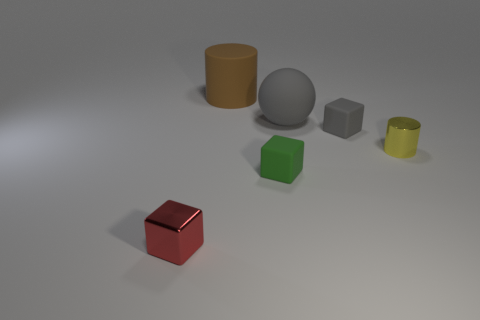What number of other objects are the same material as the small yellow cylinder?
Offer a terse response. 1. Are there the same number of large rubber objects in front of the tiny red metal block and tiny things left of the rubber cylinder?
Your answer should be compact. No. What is the color of the small rubber object that is behind the small object that is on the right side of the tiny cube behind the small yellow cylinder?
Keep it short and to the point. Gray. There is a metallic object that is on the right side of the brown matte object; what shape is it?
Your answer should be compact. Cylinder. The other gray object that is the same material as the small gray thing is what shape?
Provide a short and direct response. Sphere. Is there anything else that is the same shape as the big gray thing?
Offer a terse response. No. There is a large brown cylinder; how many red metallic objects are to the right of it?
Give a very brief answer. 0. Are there the same number of small matte blocks that are right of the big gray thing and tiny shiny cylinders?
Provide a short and direct response. Yes. Do the big brown cylinder and the yellow thing have the same material?
Offer a very short reply. No. There is a thing that is both on the right side of the big matte ball and behind the yellow metallic cylinder; what size is it?
Provide a short and direct response. Small. 